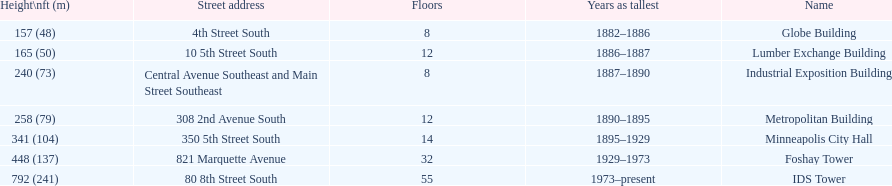Is the metropolitan building or the lumber exchange building taller? Metropolitan Building. 